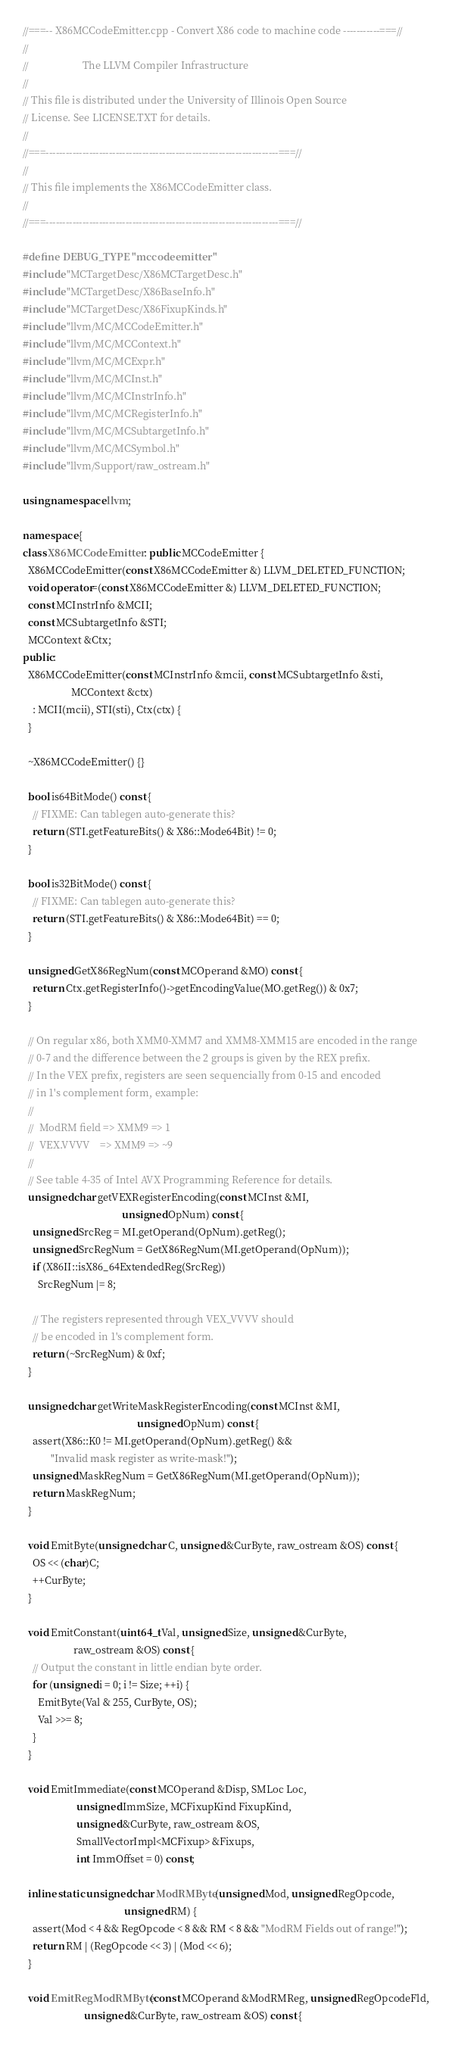<code> <loc_0><loc_0><loc_500><loc_500><_C++_>//===-- X86MCCodeEmitter.cpp - Convert X86 code to machine code -----------===//
//
//                     The LLVM Compiler Infrastructure
//
// This file is distributed under the University of Illinois Open Source
// License. See LICENSE.TXT for details.
//
//===----------------------------------------------------------------------===//
//
// This file implements the X86MCCodeEmitter class.
//
//===----------------------------------------------------------------------===//

#define DEBUG_TYPE "mccodeemitter"
#include "MCTargetDesc/X86MCTargetDesc.h"
#include "MCTargetDesc/X86BaseInfo.h"
#include "MCTargetDesc/X86FixupKinds.h"
#include "llvm/MC/MCCodeEmitter.h"
#include "llvm/MC/MCContext.h"
#include "llvm/MC/MCExpr.h"
#include "llvm/MC/MCInst.h"
#include "llvm/MC/MCInstrInfo.h"
#include "llvm/MC/MCRegisterInfo.h"
#include "llvm/MC/MCSubtargetInfo.h"
#include "llvm/MC/MCSymbol.h"
#include "llvm/Support/raw_ostream.h"

using namespace llvm;

namespace {
class X86MCCodeEmitter : public MCCodeEmitter {
  X86MCCodeEmitter(const X86MCCodeEmitter &) LLVM_DELETED_FUNCTION;
  void operator=(const X86MCCodeEmitter &) LLVM_DELETED_FUNCTION;
  const MCInstrInfo &MCII;
  const MCSubtargetInfo &STI;
  MCContext &Ctx;
public:
  X86MCCodeEmitter(const MCInstrInfo &mcii, const MCSubtargetInfo &sti,
                   MCContext &ctx)
    : MCII(mcii), STI(sti), Ctx(ctx) {
  }

  ~X86MCCodeEmitter() {}

  bool is64BitMode() const {
    // FIXME: Can tablegen auto-generate this?
    return (STI.getFeatureBits() & X86::Mode64Bit) != 0;
  }

  bool is32BitMode() const {
    // FIXME: Can tablegen auto-generate this?
    return (STI.getFeatureBits() & X86::Mode64Bit) == 0;
  }

  unsigned GetX86RegNum(const MCOperand &MO) const {
    return Ctx.getRegisterInfo()->getEncodingValue(MO.getReg()) & 0x7;
  }

  // On regular x86, both XMM0-XMM7 and XMM8-XMM15 are encoded in the range
  // 0-7 and the difference between the 2 groups is given by the REX prefix.
  // In the VEX prefix, registers are seen sequencially from 0-15 and encoded
  // in 1's complement form, example:
  //
  //  ModRM field => XMM9 => 1
  //  VEX.VVVV    => XMM9 => ~9
  //
  // See table 4-35 of Intel AVX Programming Reference for details.
  unsigned char getVEXRegisterEncoding(const MCInst &MI,
                                       unsigned OpNum) const {
    unsigned SrcReg = MI.getOperand(OpNum).getReg();
    unsigned SrcRegNum = GetX86RegNum(MI.getOperand(OpNum));
    if (X86II::isX86_64ExtendedReg(SrcReg))
      SrcRegNum |= 8;

    // The registers represented through VEX_VVVV should
    // be encoded in 1's complement form.
    return (~SrcRegNum) & 0xf;
  }

  unsigned char getWriteMaskRegisterEncoding(const MCInst &MI,
                                             unsigned OpNum) const {
    assert(X86::K0 != MI.getOperand(OpNum).getReg() &&
           "Invalid mask register as write-mask!");
    unsigned MaskRegNum = GetX86RegNum(MI.getOperand(OpNum));
    return MaskRegNum;
  }

  void EmitByte(unsigned char C, unsigned &CurByte, raw_ostream &OS) const {
    OS << (char)C;
    ++CurByte;
  }

  void EmitConstant(uint64_t Val, unsigned Size, unsigned &CurByte,
                    raw_ostream &OS) const {
    // Output the constant in little endian byte order.
    for (unsigned i = 0; i != Size; ++i) {
      EmitByte(Val & 255, CurByte, OS);
      Val >>= 8;
    }
  }

  void EmitImmediate(const MCOperand &Disp, SMLoc Loc,
                     unsigned ImmSize, MCFixupKind FixupKind,
                     unsigned &CurByte, raw_ostream &OS,
                     SmallVectorImpl<MCFixup> &Fixups,
                     int ImmOffset = 0) const;

  inline static unsigned char ModRMByte(unsigned Mod, unsigned RegOpcode,
                                        unsigned RM) {
    assert(Mod < 4 && RegOpcode < 8 && RM < 8 && "ModRM Fields out of range!");
    return RM | (RegOpcode << 3) | (Mod << 6);
  }

  void EmitRegModRMByte(const MCOperand &ModRMReg, unsigned RegOpcodeFld,
                        unsigned &CurByte, raw_ostream &OS) const {</code> 